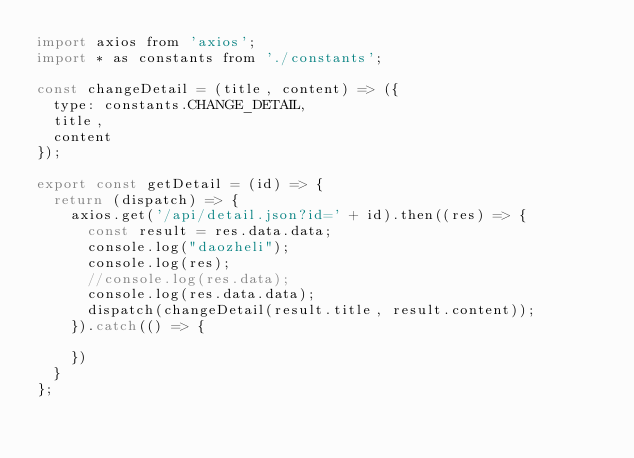<code> <loc_0><loc_0><loc_500><loc_500><_JavaScript_>import axios from 'axios';
import * as constants from './constants';

const changeDetail = (title, content) => ({
	type: constants.CHANGE_DETAIL,
	title,
	content
});

export const getDetail = (id) => {
	return (dispatch) => {
		axios.get('/api/detail.json?id=' + id).then((res) => {
			const result = res.data.data;
			console.log("daozheli");
			console.log(res);
			//console.log(res.data);
			console.log(res.data.data);
			dispatch(changeDetail(result.title, result.content));
		}).catch(() => {
			
		})
	}
};</code> 